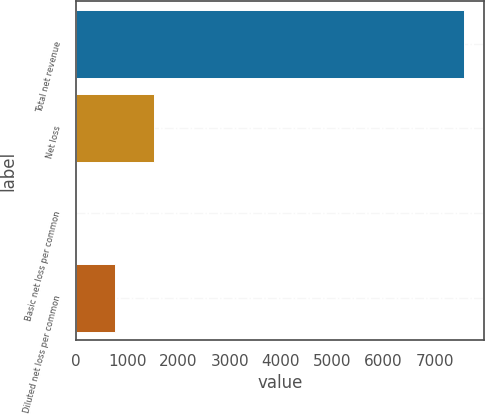<chart> <loc_0><loc_0><loc_500><loc_500><bar_chart><fcel>Total net revenue<fcel>Net loss<fcel>Basic net loss per common<fcel>Diluted net loss per common<nl><fcel>7579<fcel>1516.87<fcel>1.33<fcel>759.1<nl></chart> 